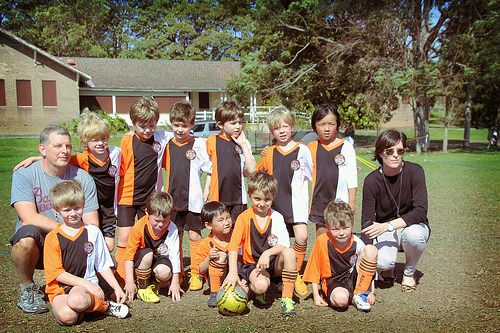<image>
Can you confirm if the man is under the boy? No. The man is not positioned under the boy. The vertical relationship between these objects is different. 